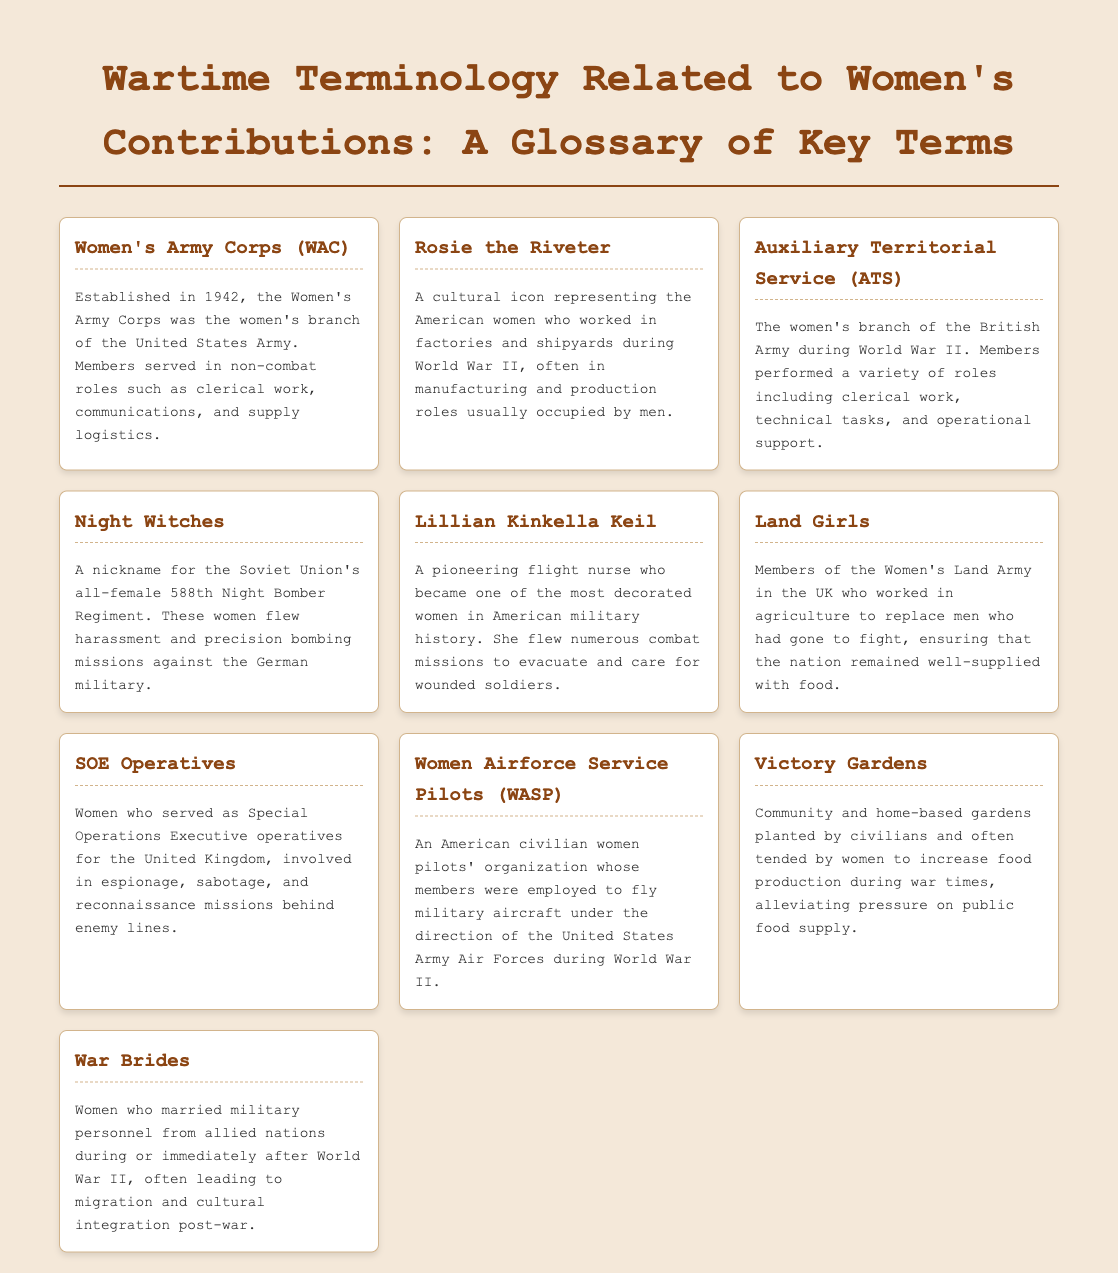What does WAC stand for? WAC stands for Women's Army Corps, which is described in the document as the women's branch of the United States Army.
Answer: Women's Army Corps Who is a cultural icon representing women who worked in factories during the war? The document mentions Rosie the Riveter as the cultural icon for American women working in factories and shipyards during World War II.
Answer: Rosie the Riveter What was the nickname of the Soviet Union's all-female bombing regiment? The document refers to the Soviet Union's all-female 588th Night Bomber Regiment as the Night Witches.
Answer: Night Witches Which group of women worked in agriculture in the UK during the war? The document mentions the Women's Land Army as the group of women that worked in agriculture during World War II.
Answer: Land Girls What role did Lillian Kinkella Keil serve in during the war? The document states that Lillian Kinkella Keil was a pioneering flight nurse, becoming one of the most decorated women in American military history.
Answer: Flight nurse What did the term "Victory Gardens" refer to? In the document, Victory Gardens are described as community and home-based gardens planted by civilians to increase food production during war times.
Answer: Community gardens How many key terms are listed in this glossary? The number of key terms listed in the document consists of ten distinct terms, each with a definition.
Answer: Ten Which organization did Women Airforce Service Pilots belong to? The document identifies the Women Airforce Service Pilots as an American civilian women pilots' organization.
Answer: American civilian women pilots' organization What activities were SOE Operatives involved in? According to the document, SOE Operatives were involved in espionage, sabotage, and reconnaissance missions behind enemy lines.
Answer: Espionage, sabotage, reconnaissance What is the significance of War Brides in World War II context? The document explains that War Brides are women who married military personnel from allied nations during or after World War II, affecting migration and cultural integration.
Answer: Cultural integration 